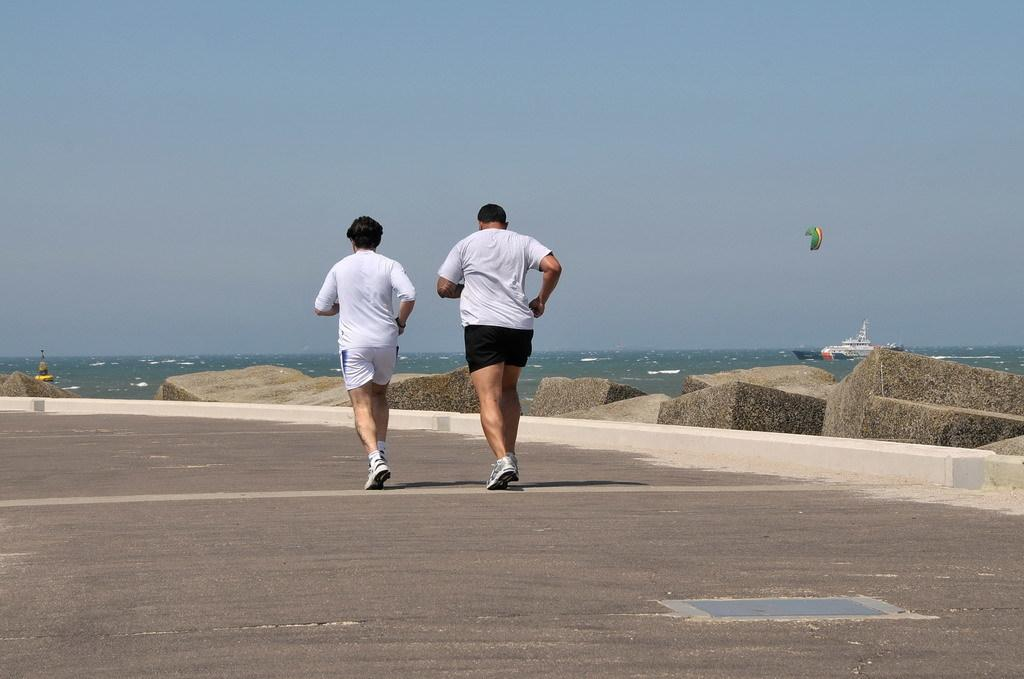What are the two men in the foreground doing? The two men are running on the road in the foreground. What can be seen in the background of the image? In the background, there are stones, water, a ship, a parachute, and the sky. Can you describe the water in the background? The water in the background is visible near the ship. What is present in the air in the background? There is a parachute in the air in the background. What type of statement can be seen written on the parachute in the image? There is no statement visible on the parachute in the image; it is simply a parachute in the air. What color are the lips of the ship in the image? There are no lips present in the image, as it features a ship on the water. 